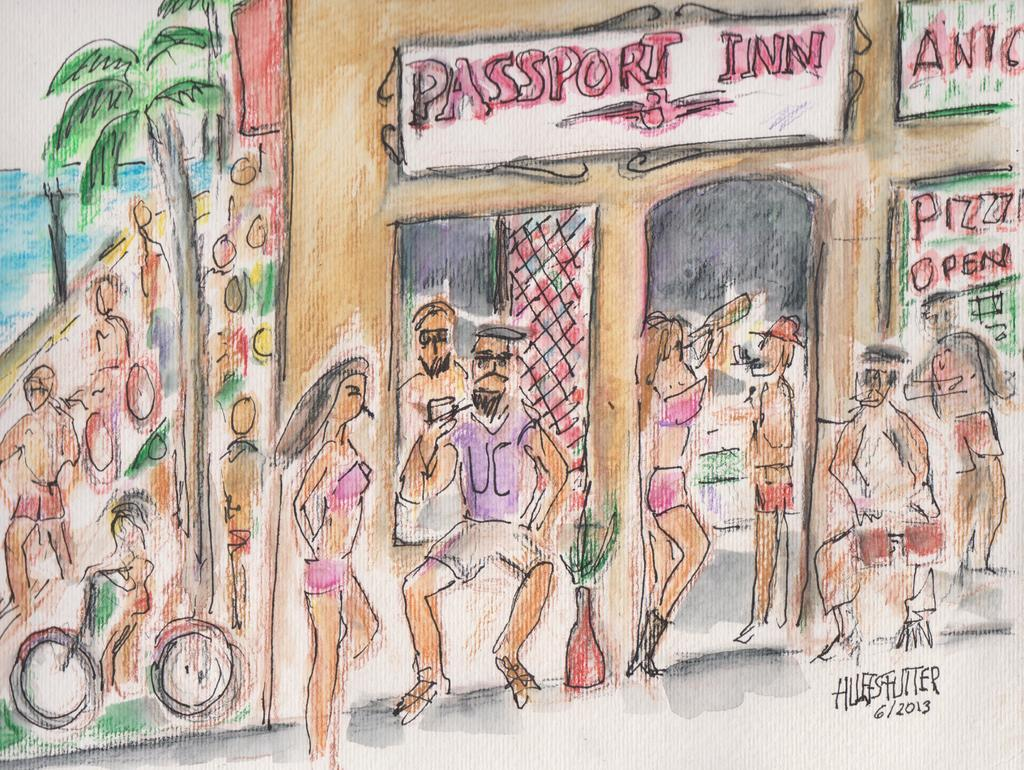What can be seen in the image? There are people standing in the image, there is a building, a tree, water, sky, and a bicycle. Can you describe the setting of the image? The image shows people standing near a building, with a tree, water, and sky in the background. There is also a bicycle present. Is there any text or marking on the image? Yes, there is a signature on the image. Reasoning: Let' Let's think step by step in order to produce the conversation. We start by identifying the main subjects and objects in the image based on the provided facts. We then formulate questions that focus on the location and characteristics of these subjects and objects, ensuring that each question can be answered definitively with the information given. We avoid yes/no questions and ensure that the language is simple and clear. Absurd Question/Answer: What type of magic is being performed with the train in the image? There is no train present in the image, and therefore no magic or train-related activities can be observed. What kind of apparatus is being used by the people in the image? The image does not show any specific apparatus being used by the people; they are simply standing in the scene. 